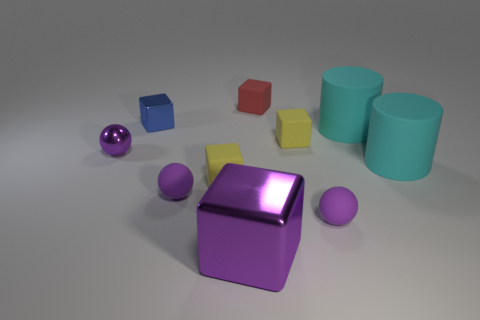Subtract all brown cubes. Subtract all gray cylinders. How many cubes are left? 5 Subtract all balls. How many objects are left? 7 Add 10 large brown matte balls. How many large brown matte balls exist? 10 Subtract 0 green cylinders. How many objects are left? 10 Subtract all blocks. Subtract all cyan rubber objects. How many objects are left? 3 Add 9 tiny blue shiny cubes. How many tiny blue shiny cubes are left? 10 